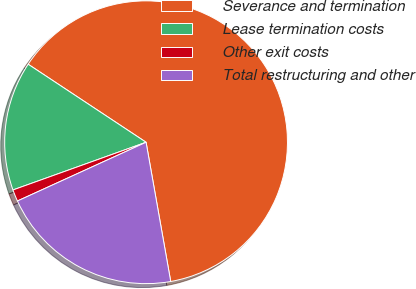Convert chart to OTSL. <chart><loc_0><loc_0><loc_500><loc_500><pie_chart><fcel>Severance and termination<fcel>Lease termination costs<fcel>Other exit costs<fcel>Total restructuring and other<nl><fcel>62.9%<fcel>14.78%<fcel>1.34%<fcel>20.97%<nl></chart> 